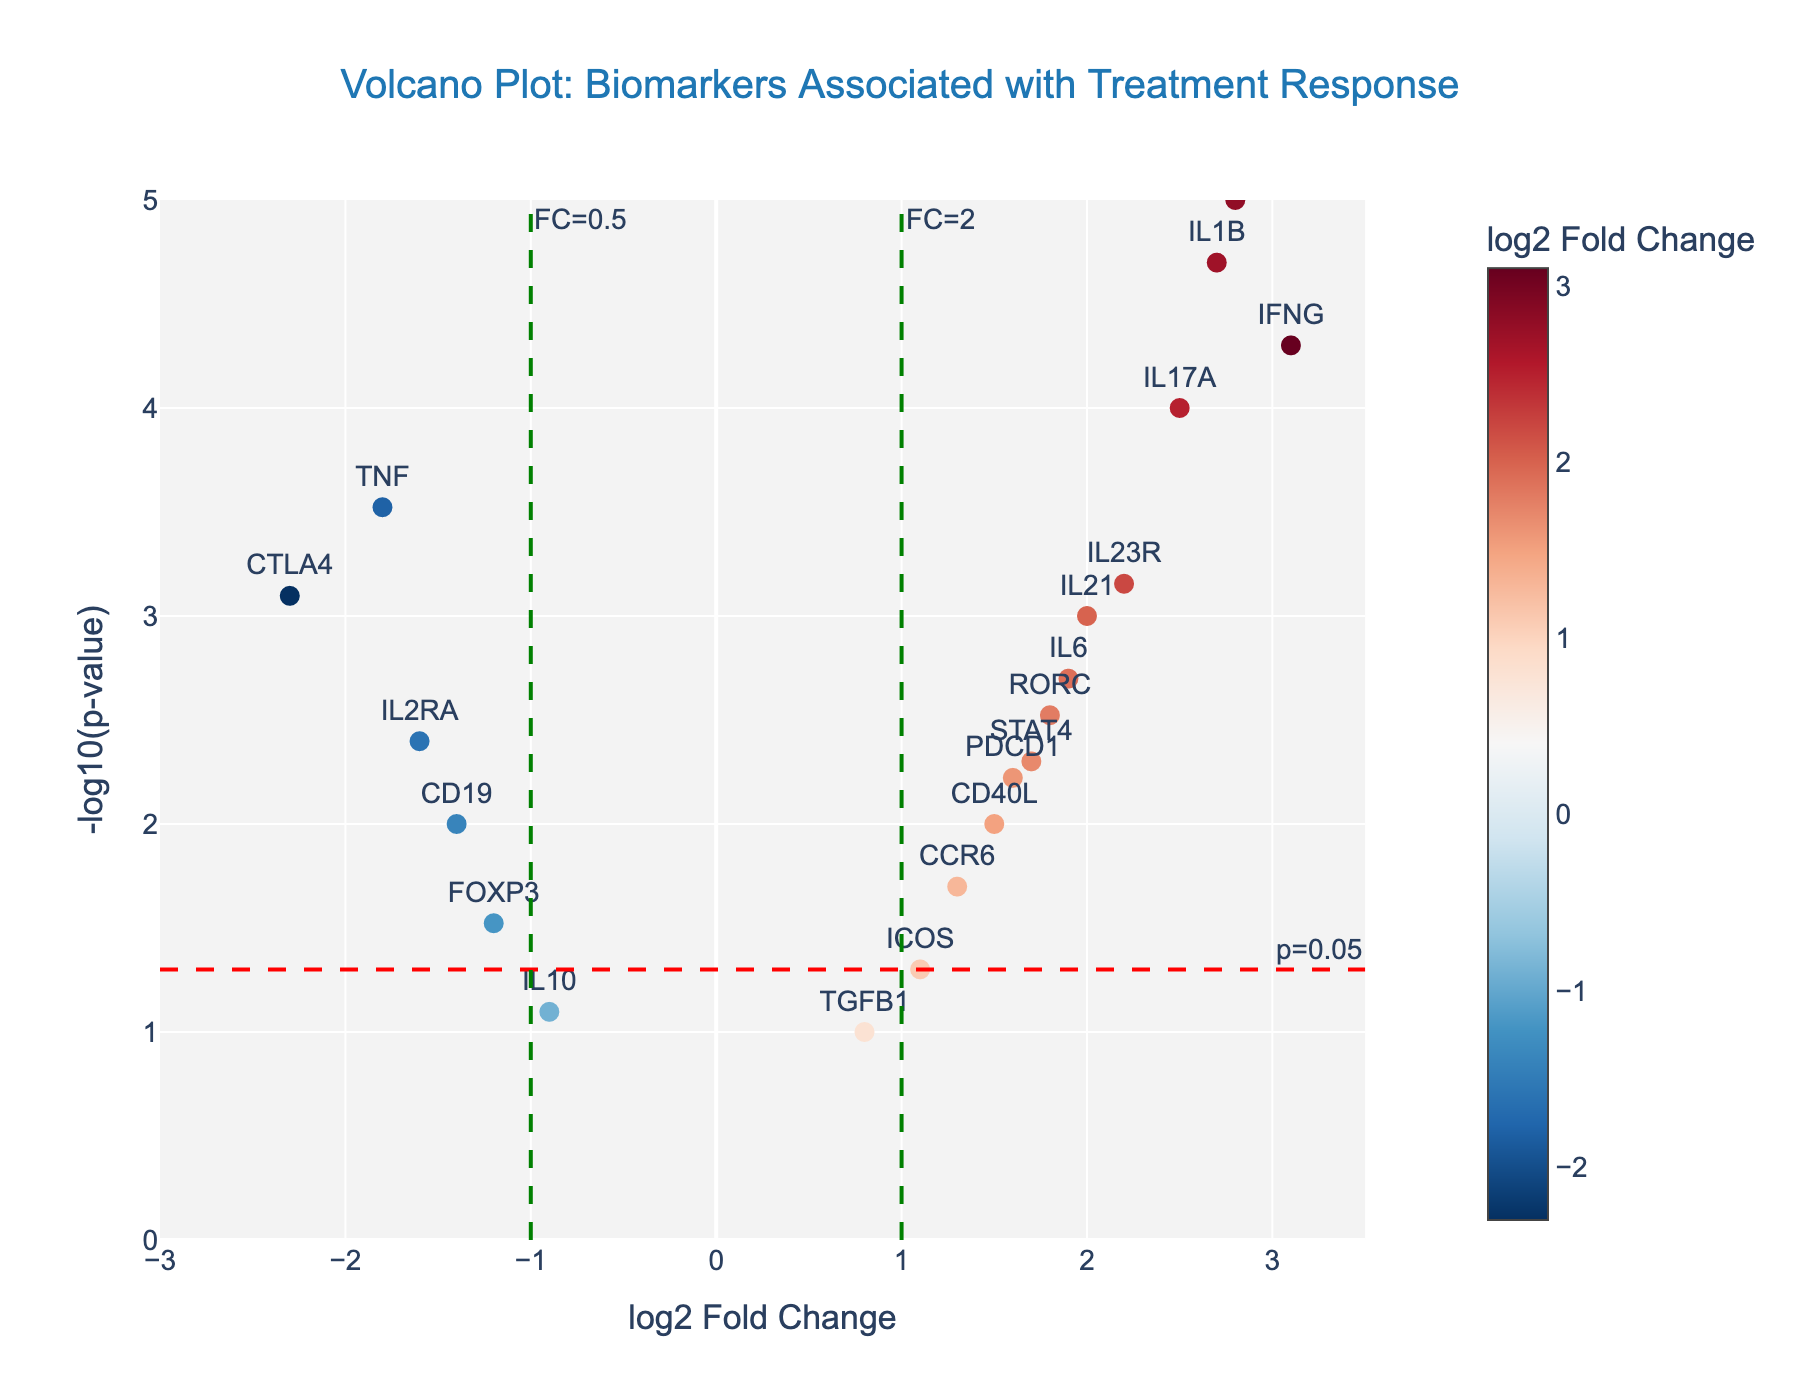What is the title of the plot? The title is located at the top of the plot. The text reads "Volcano Plot: Biomarkers Associated with Treatment Response".
Answer: "Volcano Plot: Biomarkers Associated with Treatment Response" What do the x and y-axes represent in the plot? The x-axis shows log2 Fold Change and the y-axis shows -log10(p-value). These are the titles visible on the respective axes of the plot.
Answer: x-axis: log2 Fold Change, y-axis: -log10(p-value) How many data points are shown in the plot? By counting the markers, we can see there are 20 data points in the plot.
Answer: 20 Which gene has the highest log2 Fold Change? The plot shows the genes by name and hover text. By identifying the highest x-axis value, we can see that IFNG has the highest log2 Fold Change of 3.1.
Answer: IFNG Which gene has the lowest p-value? The plot shows that the smallest p-value (highest y-axis value) corresponds to the gene CXCL13, with a -log10(p-value) of around 5.
Answer: CXCL13 How many genes have a p-value less than 0.05? The horizontal red dashed line indicates the p-value threshold of 0.05 (-log10(p-value) is 1.3). Count the number of points above this line. There are 16 genes above this threshold.
Answer: 16 How many genes have both a log2 Fold Change greater than 1 and a p-value less than 0.05? We need to count the number of points that are to the right of the vertical green dashed line at log2 Fold Change of 1 and above the red dashed line (-log10(p-value) = 1.3). There are 9 genes meeting both criteria.
Answer: 9 Which gene has the smallest negative log2 Fold Change? The plot shows the smallest negative log2 Fold Change around -2.3, which corresponds to the gene CTLA4.
Answer: CTLA4 Is IL21 statistically significant? We need to check if IL21 is above the p-value threshold line at -log10(p-value) = 1.3. The hover text shows p-value is 0.001, indicating it's significant.
Answer: Yes Comparing IL17A and TNF, which one has a higher fold change? Look at the log2 Fold Change values for IL17A and TNF. IL17A has a log2 Fold Change of 2.5, while TNF has -1.8. IL17A has a higher value.
Answer: IL17A Question Explanation
Answer: Concise Answer 